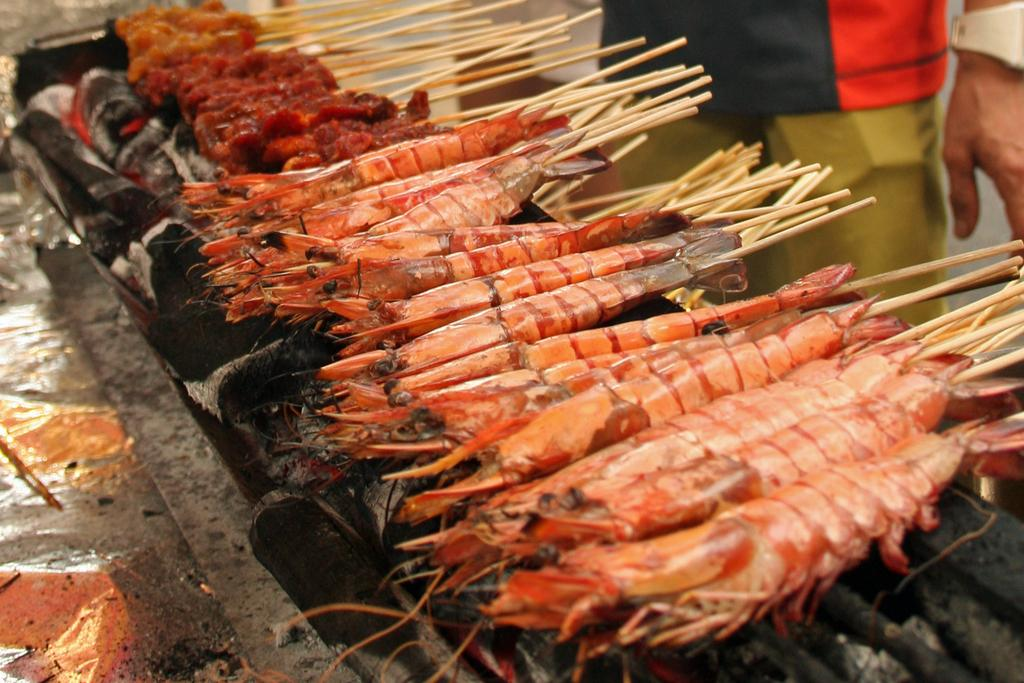What type of food is being cooked on the grill in the image? There are shrimp skewers on a grill in the image. Can you describe the person in the image? A person is standing at the back in the image. What type of boat is visible in the image? There is no boat present in the image. Is there a volleyball game happening in the image? There is no volleyball game or any reference to a volleyball in the image. 